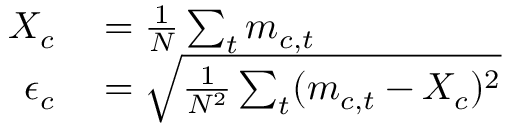<formula> <loc_0><loc_0><loc_500><loc_500>\begin{array} { r l } { X _ { c } } & = \frac { 1 } { N } \sum _ { t } m _ { c , t } } \\ { \epsilon _ { c } } & = \sqrt { \frac { 1 } { N ^ { 2 } } \sum _ { t } ( m _ { c , t } - X _ { c } ) ^ { 2 } } } \end{array}</formula> 